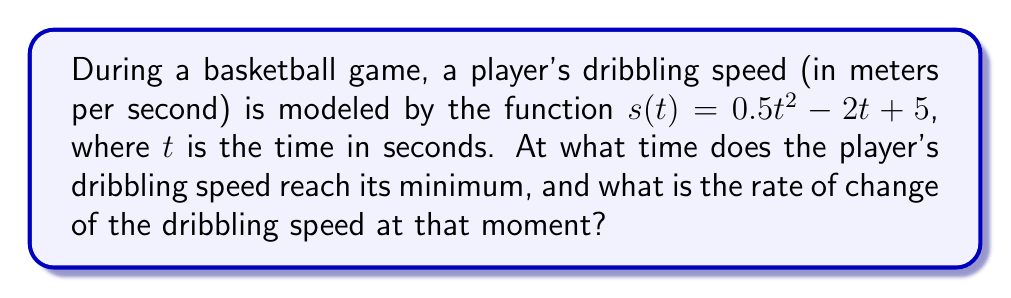Solve this math problem. To solve this problem, we'll follow these steps:

1) First, we need to find the minimum point of the speed function. This occurs where the derivative of $s(t)$ is zero.

2) Let's find the derivative of $s(t)$:
   $$s'(t) = \frac{d}{dt}(0.5t^2 - 2t + 5) = t - 2$$

3) Set $s'(t) = 0$ and solve for $t$:
   $$t - 2 = 0$$
   $$t = 2$$

4) This tells us that the minimum speed occurs at $t = 2$ seconds.

5) To find the rate of change at this point, we need to find the second derivative of $s(t)$:
   $$s''(t) = \frac{d}{dt}(t - 2) = 1$$

6) The second derivative is constant and equal to 1, which means the rate of change of the dribbling speed is always 1 m/s^2, including at the minimum point.

Therefore, the player's dribbling speed reaches its minimum at $t = 2$ seconds, and the rate of change of the dribbling speed at that moment is 1 m/s^2.
Answer: $t = 2$ seconds, rate of change = 1 m/s^2 